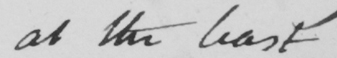What does this handwritten line say? at the least 